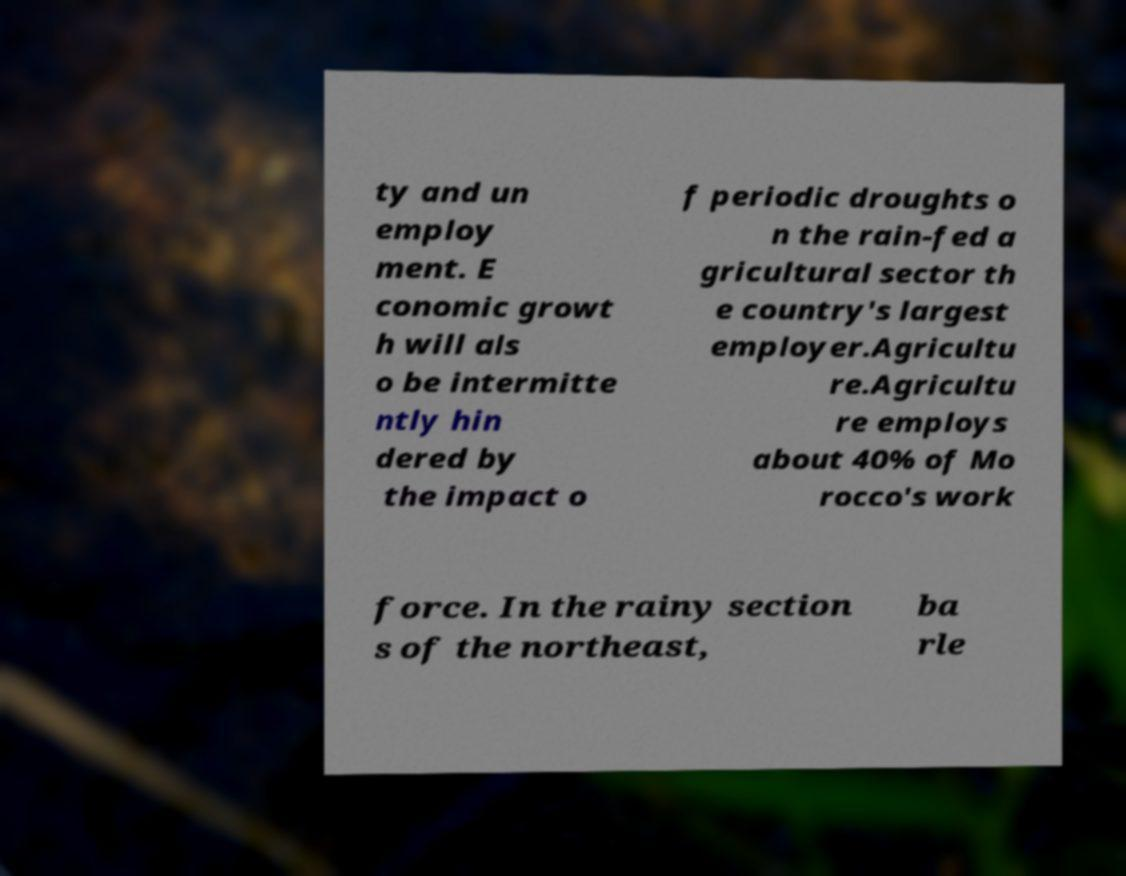For documentation purposes, I need the text within this image transcribed. Could you provide that? ty and un employ ment. E conomic growt h will als o be intermitte ntly hin dered by the impact o f periodic droughts o n the rain-fed a gricultural sector th e country's largest employer.Agricultu re.Agricultu re employs about 40% of Mo rocco's work force. In the rainy section s of the northeast, ba rle 